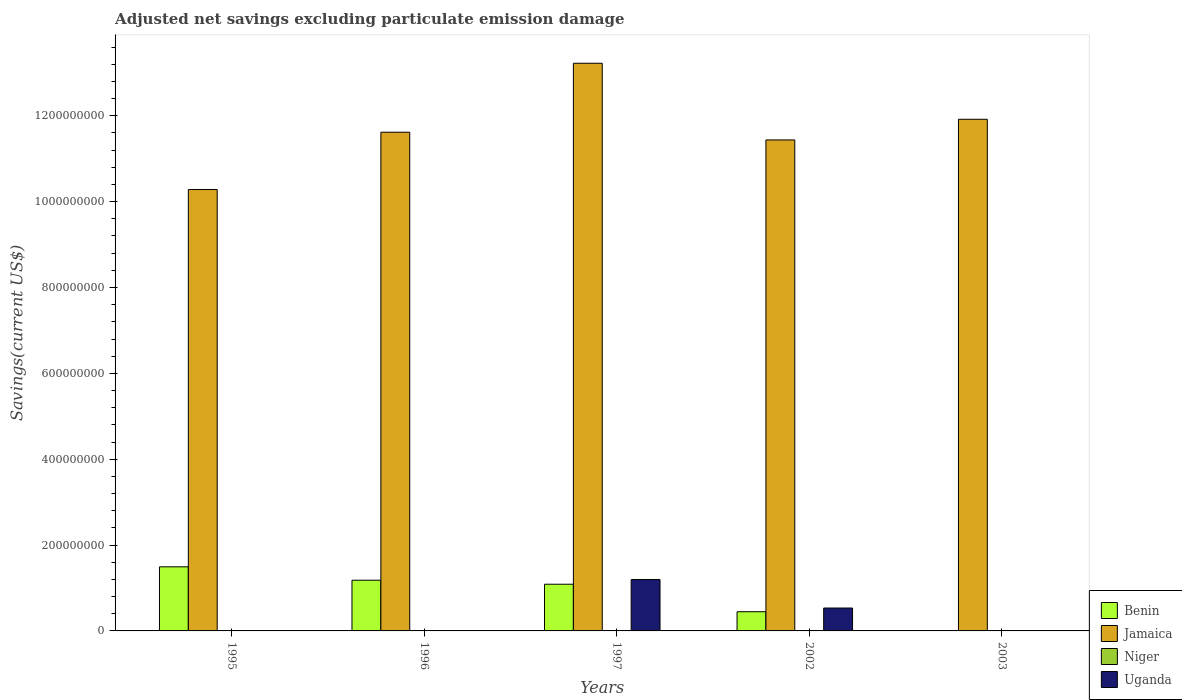How many different coloured bars are there?
Give a very brief answer. 3. Are the number of bars on each tick of the X-axis equal?
Ensure brevity in your answer.  No. What is the label of the 1st group of bars from the left?
Provide a short and direct response. 1995. In how many cases, is the number of bars for a given year not equal to the number of legend labels?
Keep it short and to the point. 5. Across all years, what is the maximum adjusted net savings in Jamaica?
Keep it short and to the point. 1.32e+09. In which year was the adjusted net savings in Benin maximum?
Offer a very short reply. 1995. What is the difference between the adjusted net savings in Jamaica in 1997 and that in 2002?
Your response must be concise. 1.79e+08. What is the difference between the adjusted net savings in Jamaica in 2003 and the adjusted net savings in Benin in 1997?
Provide a succinct answer. 1.08e+09. What is the average adjusted net savings in Jamaica per year?
Offer a very short reply. 1.17e+09. In the year 1995, what is the difference between the adjusted net savings in Jamaica and adjusted net savings in Benin?
Offer a terse response. 8.79e+08. What is the ratio of the adjusted net savings in Benin in 1996 to that in 2002?
Offer a terse response. 2.64. Is the adjusted net savings in Benin in 1995 less than that in 1997?
Offer a very short reply. No. What is the difference between the highest and the second highest adjusted net savings in Jamaica?
Give a very brief answer. 1.30e+08. What is the difference between the highest and the lowest adjusted net savings in Uganda?
Your answer should be very brief. 1.20e+08. How many years are there in the graph?
Offer a terse response. 5. What is the difference between two consecutive major ticks on the Y-axis?
Your response must be concise. 2.00e+08. Are the values on the major ticks of Y-axis written in scientific E-notation?
Your answer should be very brief. No. Does the graph contain any zero values?
Your answer should be very brief. Yes. Does the graph contain grids?
Ensure brevity in your answer.  No. What is the title of the graph?
Your answer should be compact. Adjusted net savings excluding particulate emission damage. What is the label or title of the Y-axis?
Your answer should be very brief. Savings(current US$). What is the Savings(current US$) in Benin in 1995?
Your response must be concise. 1.49e+08. What is the Savings(current US$) in Jamaica in 1995?
Offer a terse response. 1.03e+09. What is the Savings(current US$) of Niger in 1995?
Give a very brief answer. 0. What is the Savings(current US$) of Uganda in 1995?
Ensure brevity in your answer.  0. What is the Savings(current US$) of Benin in 1996?
Keep it short and to the point. 1.18e+08. What is the Savings(current US$) in Jamaica in 1996?
Your response must be concise. 1.16e+09. What is the Savings(current US$) of Niger in 1996?
Offer a terse response. 0. What is the Savings(current US$) in Benin in 1997?
Give a very brief answer. 1.09e+08. What is the Savings(current US$) in Jamaica in 1997?
Your response must be concise. 1.32e+09. What is the Savings(current US$) of Niger in 1997?
Offer a very short reply. 0. What is the Savings(current US$) of Uganda in 1997?
Keep it short and to the point. 1.20e+08. What is the Savings(current US$) in Benin in 2002?
Ensure brevity in your answer.  4.47e+07. What is the Savings(current US$) in Jamaica in 2002?
Your response must be concise. 1.14e+09. What is the Savings(current US$) of Niger in 2002?
Offer a terse response. 0. What is the Savings(current US$) of Uganda in 2002?
Your response must be concise. 5.33e+07. What is the Savings(current US$) in Benin in 2003?
Ensure brevity in your answer.  0. What is the Savings(current US$) in Jamaica in 2003?
Provide a succinct answer. 1.19e+09. Across all years, what is the maximum Savings(current US$) in Benin?
Offer a terse response. 1.49e+08. Across all years, what is the maximum Savings(current US$) of Jamaica?
Provide a succinct answer. 1.32e+09. Across all years, what is the maximum Savings(current US$) of Uganda?
Keep it short and to the point. 1.20e+08. Across all years, what is the minimum Savings(current US$) of Benin?
Offer a terse response. 0. Across all years, what is the minimum Savings(current US$) in Jamaica?
Your response must be concise. 1.03e+09. What is the total Savings(current US$) in Benin in the graph?
Provide a succinct answer. 4.21e+08. What is the total Savings(current US$) in Jamaica in the graph?
Provide a short and direct response. 5.85e+09. What is the total Savings(current US$) of Niger in the graph?
Make the answer very short. 0. What is the total Savings(current US$) in Uganda in the graph?
Keep it short and to the point. 1.73e+08. What is the difference between the Savings(current US$) in Benin in 1995 and that in 1996?
Make the answer very short. 3.12e+07. What is the difference between the Savings(current US$) of Jamaica in 1995 and that in 1996?
Your response must be concise. -1.34e+08. What is the difference between the Savings(current US$) in Benin in 1995 and that in 1997?
Your answer should be compact. 4.06e+07. What is the difference between the Savings(current US$) in Jamaica in 1995 and that in 1997?
Provide a succinct answer. -2.94e+08. What is the difference between the Savings(current US$) of Benin in 1995 and that in 2002?
Offer a terse response. 1.05e+08. What is the difference between the Savings(current US$) of Jamaica in 1995 and that in 2002?
Ensure brevity in your answer.  -1.16e+08. What is the difference between the Savings(current US$) in Jamaica in 1995 and that in 2003?
Offer a terse response. -1.64e+08. What is the difference between the Savings(current US$) of Benin in 1996 and that in 1997?
Your response must be concise. 9.37e+06. What is the difference between the Savings(current US$) in Jamaica in 1996 and that in 1997?
Your answer should be compact. -1.61e+08. What is the difference between the Savings(current US$) of Benin in 1996 and that in 2002?
Keep it short and to the point. 7.34e+07. What is the difference between the Savings(current US$) in Jamaica in 1996 and that in 2002?
Offer a very short reply. 1.80e+07. What is the difference between the Savings(current US$) of Jamaica in 1996 and that in 2003?
Offer a very short reply. -3.01e+07. What is the difference between the Savings(current US$) of Benin in 1997 and that in 2002?
Ensure brevity in your answer.  6.41e+07. What is the difference between the Savings(current US$) in Jamaica in 1997 and that in 2002?
Give a very brief answer. 1.79e+08. What is the difference between the Savings(current US$) of Uganda in 1997 and that in 2002?
Give a very brief answer. 6.64e+07. What is the difference between the Savings(current US$) in Jamaica in 1997 and that in 2003?
Provide a short and direct response. 1.30e+08. What is the difference between the Savings(current US$) in Jamaica in 2002 and that in 2003?
Your answer should be very brief. -4.81e+07. What is the difference between the Savings(current US$) in Benin in 1995 and the Savings(current US$) in Jamaica in 1996?
Ensure brevity in your answer.  -1.01e+09. What is the difference between the Savings(current US$) in Benin in 1995 and the Savings(current US$) in Jamaica in 1997?
Offer a very short reply. -1.17e+09. What is the difference between the Savings(current US$) in Benin in 1995 and the Savings(current US$) in Uganda in 1997?
Your answer should be compact. 2.96e+07. What is the difference between the Savings(current US$) in Jamaica in 1995 and the Savings(current US$) in Uganda in 1997?
Provide a succinct answer. 9.09e+08. What is the difference between the Savings(current US$) of Benin in 1995 and the Savings(current US$) of Jamaica in 2002?
Provide a short and direct response. -9.94e+08. What is the difference between the Savings(current US$) of Benin in 1995 and the Savings(current US$) of Uganda in 2002?
Ensure brevity in your answer.  9.60e+07. What is the difference between the Savings(current US$) in Jamaica in 1995 and the Savings(current US$) in Uganda in 2002?
Give a very brief answer. 9.75e+08. What is the difference between the Savings(current US$) in Benin in 1995 and the Savings(current US$) in Jamaica in 2003?
Make the answer very short. -1.04e+09. What is the difference between the Savings(current US$) in Benin in 1996 and the Savings(current US$) in Jamaica in 1997?
Provide a succinct answer. -1.20e+09. What is the difference between the Savings(current US$) in Benin in 1996 and the Savings(current US$) in Uganda in 1997?
Your response must be concise. -1.60e+06. What is the difference between the Savings(current US$) of Jamaica in 1996 and the Savings(current US$) of Uganda in 1997?
Offer a terse response. 1.04e+09. What is the difference between the Savings(current US$) of Benin in 1996 and the Savings(current US$) of Jamaica in 2002?
Offer a terse response. -1.03e+09. What is the difference between the Savings(current US$) in Benin in 1996 and the Savings(current US$) in Uganda in 2002?
Ensure brevity in your answer.  6.48e+07. What is the difference between the Savings(current US$) of Jamaica in 1996 and the Savings(current US$) of Uganda in 2002?
Make the answer very short. 1.11e+09. What is the difference between the Savings(current US$) of Benin in 1996 and the Savings(current US$) of Jamaica in 2003?
Keep it short and to the point. -1.07e+09. What is the difference between the Savings(current US$) in Benin in 1997 and the Savings(current US$) in Jamaica in 2002?
Ensure brevity in your answer.  -1.04e+09. What is the difference between the Savings(current US$) of Benin in 1997 and the Savings(current US$) of Uganda in 2002?
Your answer should be very brief. 5.54e+07. What is the difference between the Savings(current US$) of Jamaica in 1997 and the Savings(current US$) of Uganda in 2002?
Offer a terse response. 1.27e+09. What is the difference between the Savings(current US$) of Benin in 1997 and the Savings(current US$) of Jamaica in 2003?
Your answer should be very brief. -1.08e+09. What is the difference between the Savings(current US$) of Benin in 2002 and the Savings(current US$) of Jamaica in 2003?
Your response must be concise. -1.15e+09. What is the average Savings(current US$) in Benin per year?
Provide a succinct answer. 8.42e+07. What is the average Savings(current US$) of Jamaica per year?
Your answer should be compact. 1.17e+09. What is the average Savings(current US$) of Uganda per year?
Your answer should be very brief. 3.46e+07. In the year 1995, what is the difference between the Savings(current US$) of Benin and Savings(current US$) of Jamaica?
Your answer should be compact. -8.79e+08. In the year 1996, what is the difference between the Savings(current US$) of Benin and Savings(current US$) of Jamaica?
Provide a short and direct response. -1.04e+09. In the year 1997, what is the difference between the Savings(current US$) in Benin and Savings(current US$) in Jamaica?
Give a very brief answer. -1.21e+09. In the year 1997, what is the difference between the Savings(current US$) of Benin and Savings(current US$) of Uganda?
Your response must be concise. -1.10e+07. In the year 1997, what is the difference between the Savings(current US$) of Jamaica and Savings(current US$) of Uganda?
Ensure brevity in your answer.  1.20e+09. In the year 2002, what is the difference between the Savings(current US$) in Benin and Savings(current US$) in Jamaica?
Offer a very short reply. -1.10e+09. In the year 2002, what is the difference between the Savings(current US$) in Benin and Savings(current US$) in Uganda?
Provide a succinct answer. -8.63e+06. In the year 2002, what is the difference between the Savings(current US$) in Jamaica and Savings(current US$) in Uganda?
Your response must be concise. 1.09e+09. What is the ratio of the Savings(current US$) of Benin in 1995 to that in 1996?
Offer a very short reply. 1.26. What is the ratio of the Savings(current US$) in Jamaica in 1995 to that in 1996?
Your answer should be very brief. 0.89. What is the ratio of the Savings(current US$) of Benin in 1995 to that in 1997?
Offer a very short reply. 1.37. What is the ratio of the Savings(current US$) of Jamaica in 1995 to that in 1997?
Ensure brevity in your answer.  0.78. What is the ratio of the Savings(current US$) in Benin in 1995 to that in 2002?
Offer a very short reply. 3.34. What is the ratio of the Savings(current US$) in Jamaica in 1995 to that in 2002?
Your answer should be very brief. 0.9. What is the ratio of the Savings(current US$) in Jamaica in 1995 to that in 2003?
Ensure brevity in your answer.  0.86. What is the ratio of the Savings(current US$) of Benin in 1996 to that in 1997?
Give a very brief answer. 1.09. What is the ratio of the Savings(current US$) in Jamaica in 1996 to that in 1997?
Keep it short and to the point. 0.88. What is the ratio of the Savings(current US$) in Benin in 1996 to that in 2002?
Give a very brief answer. 2.64. What is the ratio of the Savings(current US$) of Jamaica in 1996 to that in 2002?
Offer a very short reply. 1.02. What is the ratio of the Savings(current US$) of Jamaica in 1996 to that in 2003?
Offer a very short reply. 0.97. What is the ratio of the Savings(current US$) in Benin in 1997 to that in 2002?
Ensure brevity in your answer.  2.43. What is the ratio of the Savings(current US$) in Jamaica in 1997 to that in 2002?
Keep it short and to the point. 1.16. What is the ratio of the Savings(current US$) in Uganda in 1997 to that in 2002?
Offer a terse response. 2.25. What is the ratio of the Savings(current US$) in Jamaica in 1997 to that in 2003?
Offer a very short reply. 1.11. What is the ratio of the Savings(current US$) of Jamaica in 2002 to that in 2003?
Give a very brief answer. 0.96. What is the difference between the highest and the second highest Savings(current US$) in Benin?
Provide a short and direct response. 3.12e+07. What is the difference between the highest and the second highest Savings(current US$) in Jamaica?
Your answer should be compact. 1.30e+08. What is the difference between the highest and the lowest Savings(current US$) in Benin?
Give a very brief answer. 1.49e+08. What is the difference between the highest and the lowest Savings(current US$) in Jamaica?
Offer a very short reply. 2.94e+08. What is the difference between the highest and the lowest Savings(current US$) in Uganda?
Give a very brief answer. 1.20e+08. 